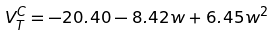Convert formula to latex. <formula><loc_0><loc_0><loc_500><loc_500>V ^ { C } _ { T } = - 2 0 . 4 0 - 8 . 4 2 w + 6 . 4 5 w ^ { 2 }</formula> 